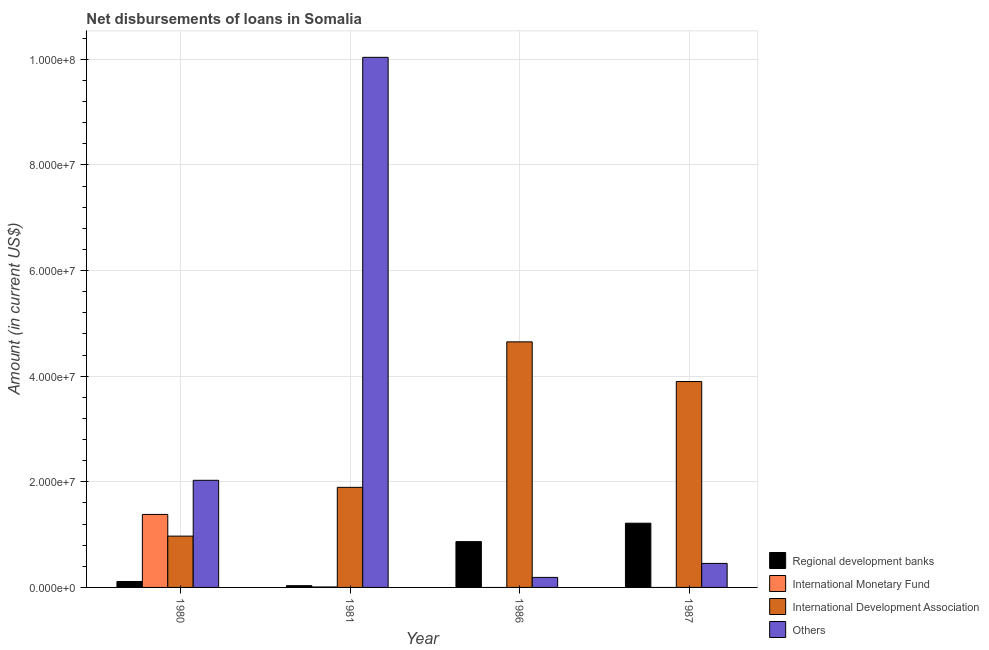Are the number of bars per tick equal to the number of legend labels?
Your answer should be compact. No. Are the number of bars on each tick of the X-axis equal?
Keep it short and to the point. No. What is the amount of loan disimbursed by regional development banks in 1986?
Your answer should be very brief. 8.67e+06. Across all years, what is the maximum amount of loan disimbursed by international monetary fund?
Provide a succinct answer. 1.38e+07. What is the total amount of loan disimbursed by other organisations in the graph?
Provide a short and direct response. 1.27e+08. What is the difference between the amount of loan disimbursed by international development association in 1980 and that in 1981?
Keep it short and to the point. -9.24e+06. What is the difference between the amount of loan disimbursed by international monetary fund in 1981 and the amount of loan disimbursed by other organisations in 1980?
Your answer should be compact. -1.37e+07. What is the average amount of loan disimbursed by other organisations per year?
Give a very brief answer. 3.18e+07. In the year 1980, what is the difference between the amount of loan disimbursed by international monetary fund and amount of loan disimbursed by other organisations?
Give a very brief answer. 0. What is the ratio of the amount of loan disimbursed by regional development banks in 1980 to that in 1987?
Your answer should be compact. 0.09. Is the difference between the amount of loan disimbursed by international monetary fund in 1980 and 1981 greater than the difference between the amount of loan disimbursed by regional development banks in 1980 and 1981?
Your answer should be compact. No. What is the difference between the highest and the second highest amount of loan disimbursed by regional development banks?
Make the answer very short. 3.49e+06. What is the difference between the highest and the lowest amount of loan disimbursed by other organisations?
Provide a short and direct response. 9.85e+07. In how many years, is the amount of loan disimbursed by other organisations greater than the average amount of loan disimbursed by other organisations taken over all years?
Offer a terse response. 1. How many bars are there?
Your answer should be very brief. 14. How many years are there in the graph?
Ensure brevity in your answer.  4. Does the graph contain any zero values?
Offer a terse response. Yes. Where does the legend appear in the graph?
Give a very brief answer. Bottom right. How many legend labels are there?
Make the answer very short. 4. How are the legend labels stacked?
Offer a very short reply. Vertical. What is the title of the graph?
Ensure brevity in your answer.  Net disbursements of loans in Somalia. Does "Other Minerals" appear as one of the legend labels in the graph?
Offer a very short reply. No. What is the label or title of the X-axis?
Your answer should be compact. Year. What is the Amount (in current US$) of Regional development banks in 1980?
Give a very brief answer. 1.12e+06. What is the Amount (in current US$) in International Monetary Fund in 1980?
Make the answer very short. 1.38e+07. What is the Amount (in current US$) of International Development Association in 1980?
Make the answer very short. 9.72e+06. What is the Amount (in current US$) of Others in 1980?
Your answer should be very brief. 2.03e+07. What is the Amount (in current US$) in Regional development banks in 1981?
Make the answer very short. 3.31e+05. What is the Amount (in current US$) in International Monetary Fund in 1981?
Your answer should be very brief. 8.50e+04. What is the Amount (in current US$) of International Development Association in 1981?
Offer a very short reply. 1.90e+07. What is the Amount (in current US$) in Others in 1981?
Your answer should be compact. 1.00e+08. What is the Amount (in current US$) in Regional development banks in 1986?
Give a very brief answer. 8.67e+06. What is the Amount (in current US$) in International Development Association in 1986?
Ensure brevity in your answer.  4.65e+07. What is the Amount (in current US$) in Others in 1986?
Your answer should be very brief. 1.90e+06. What is the Amount (in current US$) of Regional development banks in 1987?
Offer a terse response. 1.22e+07. What is the Amount (in current US$) of International Development Association in 1987?
Your response must be concise. 3.90e+07. What is the Amount (in current US$) of Others in 1987?
Provide a short and direct response. 4.55e+06. Across all years, what is the maximum Amount (in current US$) of Regional development banks?
Ensure brevity in your answer.  1.22e+07. Across all years, what is the maximum Amount (in current US$) of International Monetary Fund?
Make the answer very short. 1.38e+07. Across all years, what is the maximum Amount (in current US$) of International Development Association?
Your response must be concise. 4.65e+07. Across all years, what is the maximum Amount (in current US$) of Others?
Your answer should be very brief. 1.00e+08. Across all years, what is the minimum Amount (in current US$) in Regional development banks?
Offer a terse response. 3.31e+05. Across all years, what is the minimum Amount (in current US$) in International Monetary Fund?
Your answer should be very brief. 0. Across all years, what is the minimum Amount (in current US$) of International Development Association?
Keep it short and to the point. 9.72e+06. Across all years, what is the minimum Amount (in current US$) in Others?
Provide a short and direct response. 1.90e+06. What is the total Amount (in current US$) of Regional development banks in the graph?
Ensure brevity in your answer.  2.23e+07. What is the total Amount (in current US$) of International Monetary Fund in the graph?
Offer a terse response. 1.39e+07. What is the total Amount (in current US$) in International Development Association in the graph?
Offer a terse response. 1.14e+08. What is the total Amount (in current US$) in Others in the graph?
Offer a terse response. 1.27e+08. What is the difference between the Amount (in current US$) of Regional development banks in 1980 and that in 1981?
Your response must be concise. 7.94e+05. What is the difference between the Amount (in current US$) in International Monetary Fund in 1980 and that in 1981?
Give a very brief answer. 1.37e+07. What is the difference between the Amount (in current US$) in International Development Association in 1980 and that in 1981?
Keep it short and to the point. -9.24e+06. What is the difference between the Amount (in current US$) of Others in 1980 and that in 1981?
Your response must be concise. -8.01e+07. What is the difference between the Amount (in current US$) in Regional development banks in 1980 and that in 1986?
Your answer should be compact. -7.55e+06. What is the difference between the Amount (in current US$) in International Development Association in 1980 and that in 1986?
Offer a very short reply. -3.68e+07. What is the difference between the Amount (in current US$) in Others in 1980 and that in 1986?
Make the answer very short. 1.84e+07. What is the difference between the Amount (in current US$) in Regional development banks in 1980 and that in 1987?
Provide a succinct answer. -1.10e+07. What is the difference between the Amount (in current US$) in International Development Association in 1980 and that in 1987?
Make the answer very short. -2.93e+07. What is the difference between the Amount (in current US$) of Others in 1980 and that in 1987?
Keep it short and to the point. 1.57e+07. What is the difference between the Amount (in current US$) of Regional development banks in 1981 and that in 1986?
Provide a succinct answer. -8.34e+06. What is the difference between the Amount (in current US$) in International Development Association in 1981 and that in 1986?
Give a very brief answer. -2.76e+07. What is the difference between the Amount (in current US$) in Others in 1981 and that in 1986?
Offer a very short reply. 9.85e+07. What is the difference between the Amount (in current US$) of Regional development banks in 1981 and that in 1987?
Your answer should be compact. -1.18e+07. What is the difference between the Amount (in current US$) of International Development Association in 1981 and that in 1987?
Provide a succinct answer. -2.00e+07. What is the difference between the Amount (in current US$) in Others in 1981 and that in 1987?
Offer a very short reply. 9.58e+07. What is the difference between the Amount (in current US$) of Regional development banks in 1986 and that in 1987?
Offer a very short reply. -3.49e+06. What is the difference between the Amount (in current US$) of International Development Association in 1986 and that in 1987?
Provide a short and direct response. 7.52e+06. What is the difference between the Amount (in current US$) in Others in 1986 and that in 1987?
Your answer should be very brief. -2.65e+06. What is the difference between the Amount (in current US$) of Regional development banks in 1980 and the Amount (in current US$) of International Monetary Fund in 1981?
Ensure brevity in your answer.  1.04e+06. What is the difference between the Amount (in current US$) in Regional development banks in 1980 and the Amount (in current US$) in International Development Association in 1981?
Offer a very short reply. -1.78e+07. What is the difference between the Amount (in current US$) in Regional development banks in 1980 and the Amount (in current US$) in Others in 1981?
Offer a terse response. -9.93e+07. What is the difference between the Amount (in current US$) in International Monetary Fund in 1980 and the Amount (in current US$) in International Development Association in 1981?
Provide a short and direct response. -5.13e+06. What is the difference between the Amount (in current US$) of International Monetary Fund in 1980 and the Amount (in current US$) of Others in 1981?
Provide a succinct answer. -8.66e+07. What is the difference between the Amount (in current US$) of International Development Association in 1980 and the Amount (in current US$) of Others in 1981?
Make the answer very short. -9.07e+07. What is the difference between the Amount (in current US$) of Regional development banks in 1980 and the Amount (in current US$) of International Development Association in 1986?
Provide a succinct answer. -4.54e+07. What is the difference between the Amount (in current US$) in Regional development banks in 1980 and the Amount (in current US$) in Others in 1986?
Offer a very short reply. -7.74e+05. What is the difference between the Amount (in current US$) of International Monetary Fund in 1980 and the Amount (in current US$) of International Development Association in 1986?
Offer a terse response. -3.27e+07. What is the difference between the Amount (in current US$) in International Monetary Fund in 1980 and the Amount (in current US$) in Others in 1986?
Give a very brief answer. 1.19e+07. What is the difference between the Amount (in current US$) of International Development Association in 1980 and the Amount (in current US$) of Others in 1986?
Offer a terse response. 7.82e+06. What is the difference between the Amount (in current US$) of Regional development banks in 1980 and the Amount (in current US$) of International Development Association in 1987?
Your response must be concise. -3.79e+07. What is the difference between the Amount (in current US$) of Regional development banks in 1980 and the Amount (in current US$) of Others in 1987?
Your answer should be very brief. -3.42e+06. What is the difference between the Amount (in current US$) in International Monetary Fund in 1980 and the Amount (in current US$) in International Development Association in 1987?
Your answer should be compact. -2.52e+07. What is the difference between the Amount (in current US$) of International Monetary Fund in 1980 and the Amount (in current US$) of Others in 1987?
Give a very brief answer. 9.28e+06. What is the difference between the Amount (in current US$) in International Development Association in 1980 and the Amount (in current US$) in Others in 1987?
Offer a terse response. 5.17e+06. What is the difference between the Amount (in current US$) in Regional development banks in 1981 and the Amount (in current US$) in International Development Association in 1986?
Give a very brief answer. -4.62e+07. What is the difference between the Amount (in current US$) in Regional development banks in 1981 and the Amount (in current US$) in Others in 1986?
Your response must be concise. -1.57e+06. What is the difference between the Amount (in current US$) of International Monetary Fund in 1981 and the Amount (in current US$) of International Development Association in 1986?
Keep it short and to the point. -4.64e+07. What is the difference between the Amount (in current US$) in International Monetary Fund in 1981 and the Amount (in current US$) in Others in 1986?
Provide a succinct answer. -1.81e+06. What is the difference between the Amount (in current US$) of International Development Association in 1981 and the Amount (in current US$) of Others in 1986?
Provide a succinct answer. 1.71e+07. What is the difference between the Amount (in current US$) of Regional development banks in 1981 and the Amount (in current US$) of International Development Association in 1987?
Keep it short and to the point. -3.87e+07. What is the difference between the Amount (in current US$) of Regional development banks in 1981 and the Amount (in current US$) of Others in 1987?
Offer a terse response. -4.22e+06. What is the difference between the Amount (in current US$) in International Monetary Fund in 1981 and the Amount (in current US$) in International Development Association in 1987?
Offer a very short reply. -3.89e+07. What is the difference between the Amount (in current US$) of International Monetary Fund in 1981 and the Amount (in current US$) of Others in 1987?
Offer a terse response. -4.46e+06. What is the difference between the Amount (in current US$) in International Development Association in 1981 and the Amount (in current US$) in Others in 1987?
Provide a succinct answer. 1.44e+07. What is the difference between the Amount (in current US$) in Regional development banks in 1986 and the Amount (in current US$) in International Development Association in 1987?
Give a very brief answer. -3.03e+07. What is the difference between the Amount (in current US$) of Regional development banks in 1986 and the Amount (in current US$) of Others in 1987?
Give a very brief answer. 4.13e+06. What is the difference between the Amount (in current US$) of International Development Association in 1986 and the Amount (in current US$) of Others in 1987?
Keep it short and to the point. 4.20e+07. What is the average Amount (in current US$) in Regional development banks per year?
Keep it short and to the point. 5.57e+06. What is the average Amount (in current US$) of International Monetary Fund per year?
Ensure brevity in your answer.  3.48e+06. What is the average Amount (in current US$) in International Development Association per year?
Provide a succinct answer. 2.85e+07. What is the average Amount (in current US$) in Others per year?
Your answer should be very brief. 3.18e+07. In the year 1980, what is the difference between the Amount (in current US$) of Regional development banks and Amount (in current US$) of International Monetary Fund?
Offer a very short reply. -1.27e+07. In the year 1980, what is the difference between the Amount (in current US$) of Regional development banks and Amount (in current US$) of International Development Association?
Your answer should be very brief. -8.59e+06. In the year 1980, what is the difference between the Amount (in current US$) in Regional development banks and Amount (in current US$) in Others?
Your answer should be compact. -1.92e+07. In the year 1980, what is the difference between the Amount (in current US$) of International Monetary Fund and Amount (in current US$) of International Development Association?
Give a very brief answer. 4.11e+06. In the year 1980, what is the difference between the Amount (in current US$) in International Monetary Fund and Amount (in current US$) in Others?
Provide a succinct answer. -6.46e+06. In the year 1980, what is the difference between the Amount (in current US$) in International Development Association and Amount (in current US$) in Others?
Provide a succinct answer. -1.06e+07. In the year 1981, what is the difference between the Amount (in current US$) of Regional development banks and Amount (in current US$) of International Monetary Fund?
Keep it short and to the point. 2.46e+05. In the year 1981, what is the difference between the Amount (in current US$) of Regional development banks and Amount (in current US$) of International Development Association?
Offer a very short reply. -1.86e+07. In the year 1981, what is the difference between the Amount (in current US$) of Regional development banks and Amount (in current US$) of Others?
Provide a succinct answer. -1.00e+08. In the year 1981, what is the difference between the Amount (in current US$) of International Monetary Fund and Amount (in current US$) of International Development Association?
Provide a succinct answer. -1.89e+07. In the year 1981, what is the difference between the Amount (in current US$) of International Monetary Fund and Amount (in current US$) of Others?
Keep it short and to the point. -1.00e+08. In the year 1981, what is the difference between the Amount (in current US$) in International Development Association and Amount (in current US$) in Others?
Make the answer very short. -8.14e+07. In the year 1986, what is the difference between the Amount (in current US$) of Regional development banks and Amount (in current US$) of International Development Association?
Give a very brief answer. -3.78e+07. In the year 1986, what is the difference between the Amount (in current US$) of Regional development banks and Amount (in current US$) of Others?
Provide a succinct answer. 6.78e+06. In the year 1986, what is the difference between the Amount (in current US$) in International Development Association and Amount (in current US$) in Others?
Offer a very short reply. 4.46e+07. In the year 1987, what is the difference between the Amount (in current US$) of Regional development banks and Amount (in current US$) of International Development Association?
Ensure brevity in your answer.  -2.68e+07. In the year 1987, what is the difference between the Amount (in current US$) of Regional development banks and Amount (in current US$) of Others?
Your answer should be very brief. 7.62e+06. In the year 1987, what is the difference between the Amount (in current US$) of International Development Association and Amount (in current US$) of Others?
Ensure brevity in your answer.  3.44e+07. What is the ratio of the Amount (in current US$) of Regional development banks in 1980 to that in 1981?
Provide a short and direct response. 3.4. What is the ratio of the Amount (in current US$) of International Monetary Fund in 1980 to that in 1981?
Your response must be concise. 162.64. What is the ratio of the Amount (in current US$) in International Development Association in 1980 to that in 1981?
Your answer should be compact. 0.51. What is the ratio of the Amount (in current US$) in Others in 1980 to that in 1981?
Provide a short and direct response. 0.2. What is the ratio of the Amount (in current US$) in Regional development banks in 1980 to that in 1986?
Make the answer very short. 0.13. What is the ratio of the Amount (in current US$) of International Development Association in 1980 to that in 1986?
Your answer should be compact. 0.21. What is the ratio of the Amount (in current US$) in Others in 1980 to that in 1986?
Provide a short and direct response. 10.68. What is the ratio of the Amount (in current US$) in Regional development banks in 1980 to that in 1987?
Your answer should be very brief. 0.09. What is the ratio of the Amount (in current US$) of International Development Association in 1980 to that in 1987?
Your response must be concise. 0.25. What is the ratio of the Amount (in current US$) in Others in 1980 to that in 1987?
Keep it short and to the point. 4.46. What is the ratio of the Amount (in current US$) of Regional development banks in 1981 to that in 1986?
Offer a terse response. 0.04. What is the ratio of the Amount (in current US$) of International Development Association in 1981 to that in 1986?
Make the answer very short. 0.41. What is the ratio of the Amount (in current US$) in Others in 1981 to that in 1986?
Offer a terse response. 52.86. What is the ratio of the Amount (in current US$) of Regional development banks in 1981 to that in 1987?
Your answer should be compact. 0.03. What is the ratio of the Amount (in current US$) in International Development Association in 1981 to that in 1987?
Give a very brief answer. 0.49. What is the ratio of the Amount (in current US$) in Others in 1981 to that in 1987?
Your response must be concise. 22.08. What is the ratio of the Amount (in current US$) of Regional development banks in 1986 to that in 1987?
Your response must be concise. 0.71. What is the ratio of the Amount (in current US$) in International Development Association in 1986 to that in 1987?
Ensure brevity in your answer.  1.19. What is the ratio of the Amount (in current US$) of Others in 1986 to that in 1987?
Your response must be concise. 0.42. What is the difference between the highest and the second highest Amount (in current US$) of Regional development banks?
Provide a succinct answer. 3.49e+06. What is the difference between the highest and the second highest Amount (in current US$) in International Development Association?
Your answer should be compact. 7.52e+06. What is the difference between the highest and the second highest Amount (in current US$) of Others?
Provide a succinct answer. 8.01e+07. What is the difference between the highest and the lowest Amount (in current US$) of Regional development banks?
Make the answer very short. 1.18e+07. What is the difference between the highest and the lowest Amount (in current US$) in International Monetary Fund?
Your answer should be compact. 1.38e+07. What is the difference between the highest and the lowest Amount (in current US$) of International Development Association?
Your response must be concise. 3.68e+07. What is the difference between the highest and the lowest Amount (in current US$) of Others?
Give a very brief answer. 9.85e+07. 